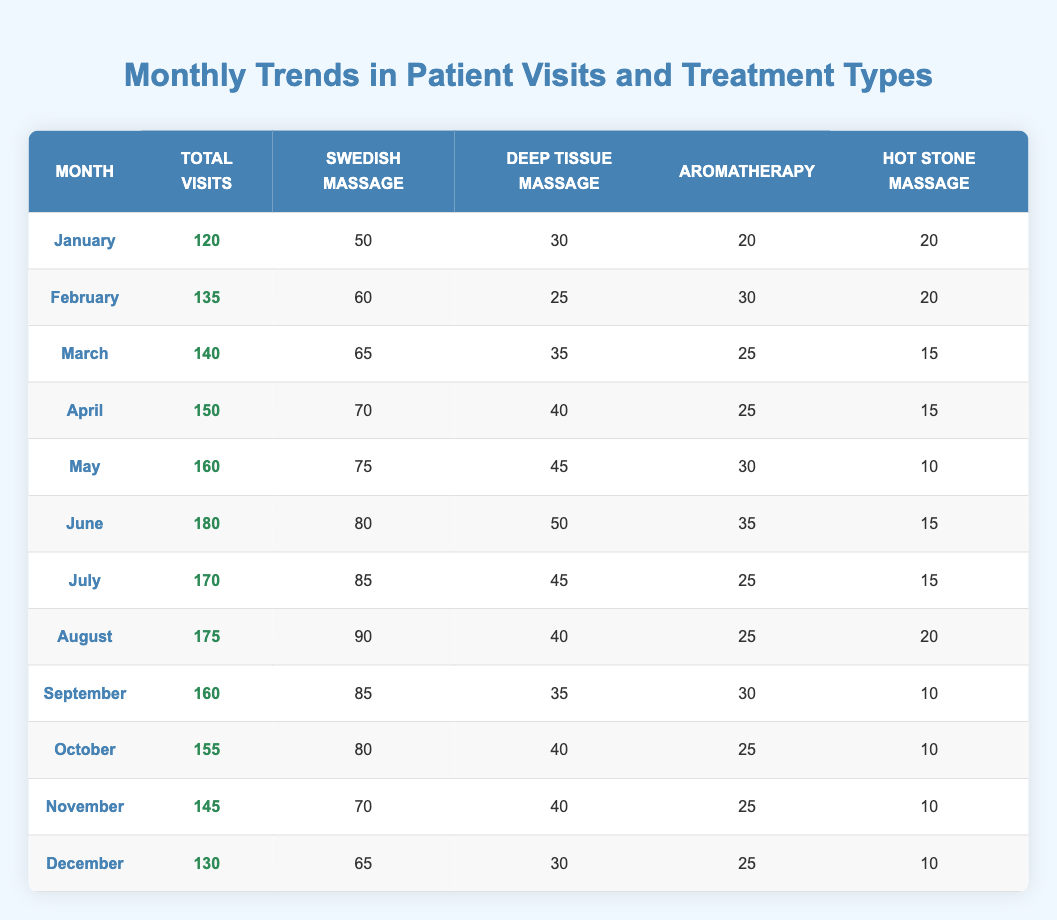What is the total number of patient visits in June? The table shows that there were 180 total visits in June. This value can be directly retrieved from the June row of the table.
Answer: 180 Which month had the highest number of Deep Tissue Massage treatments? The month with the highest number of Deep Tissue Massage treatments was June, with 50 treatments, which can be seen in the June row of the table.
Answer: June What is the average number of Swedish Massages given from January to December? To find the average number of Swedish Massages, sum up all the Swedish Massage treatments (50 + 60 + 65 + 70 + 75 + 80 + 85 + 90 + 85 + 80 + 70 + 65 =  855) and divide by 12 months, which equals 71.25.
Answer: 71.25 Did the total visits increase every month from January to June? Analyzing the total visits from January to June, we find that the visits increased from 120 (January) to 135 (February), to 140 (March), to 150 (April), to 160 (May), and finally to 180 (June), indicating consistent growth without any decrease.
Answer: Yes Which month had the most visits and the fewest Aromatherapy treatments? June had the highest total visits with 180, while February had the fewest Aromatherapy treatments, with 30. Thus, these two answers can be derived from the respective rows of the table.
Answer: June (most visits), February (fewest Aromatherapy treatments) What was the combined total of Hot Stone Massage treatments from January to December? Adding up the Hot Stone Massage treatments for each month (20 + 20 + 15 + 15 + 10 + 15 + 15 + 20 + 10 + 10 + 10 + 10 =  165) gives us a total of 165 Hot Stone Massage treatments for the year.
Answer: 165 Which month experienced the largest decrease in total visits compared to its previous month? Analyzing the total visits month-over-month, July had a decrease of 10 visits from June (180 to 170), which is the largest drop, indicating that it was the only month with a decrease compared to the previous month.
Answer: July How many more Swedish Massages were given in May compared to November? In May, there were 75 Swedish Massages, while in November, there were 70. The difference (75 - 70 = 5) indicates that 5 more Swedish Massages were given in May than in November.
Answer: 5 What percentage of total visits were Aromatherapy treatments in March? In March, there were 140 total visits and 25 Aromatherapy treatments. To find the percentage, divide the number of Aromatherapy treatments (25) by total visits (140), and then multiply by 100, resulting in approximately 17.86%.
Answer: 17.86% 